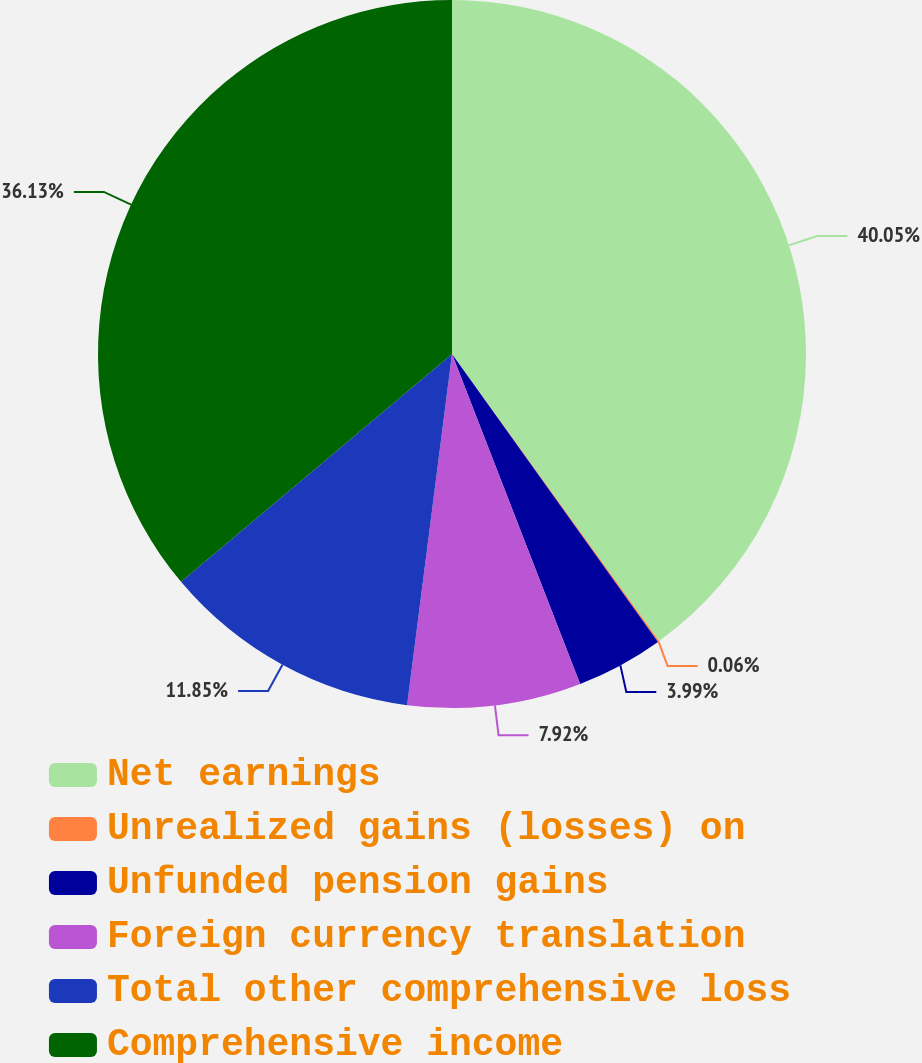<chart> <loc_0><loc_0><loc_500><loc_500><pie_chart><fcel>Net earnings<fcel>Unrealized gains (losses) on<fcel>Unfunded pension gains<fcel>Foreign currency translation<fcel>Total other comprehensive loss<fcel>Comprehensive income<nl><fcel>40.06%<fcel>0.06%<fcel>3.99%<fcel>7.92%<fcel>11.85%<fcel>36.13%<nl></chart> 